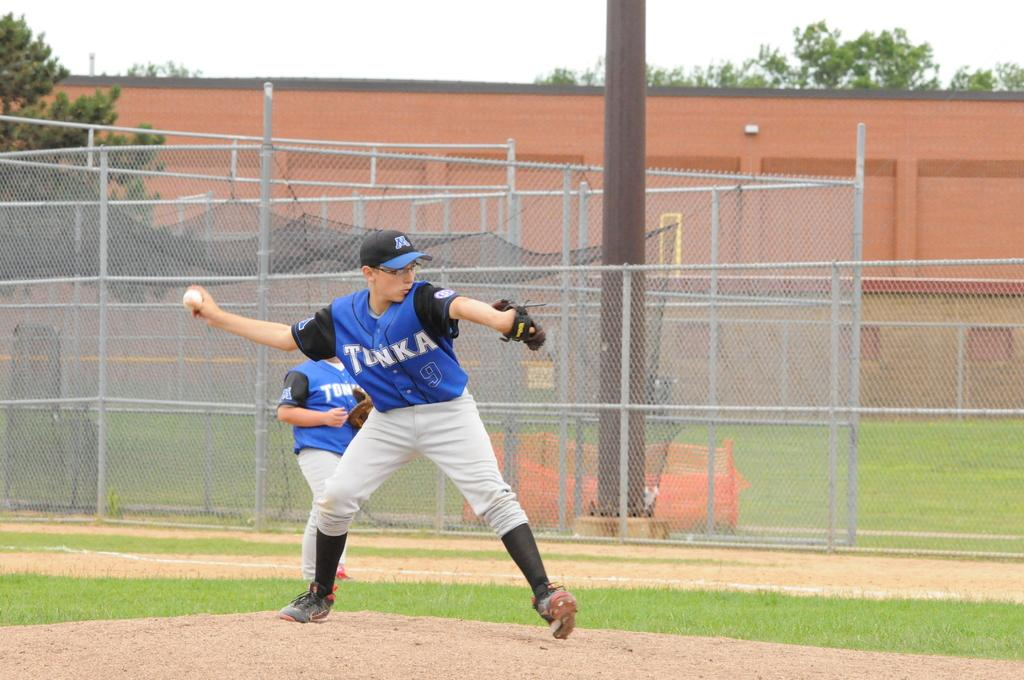<image>
Relay a brief, clear account of the picture shown. a young male baseball pitcher on the mound for the tunka team 